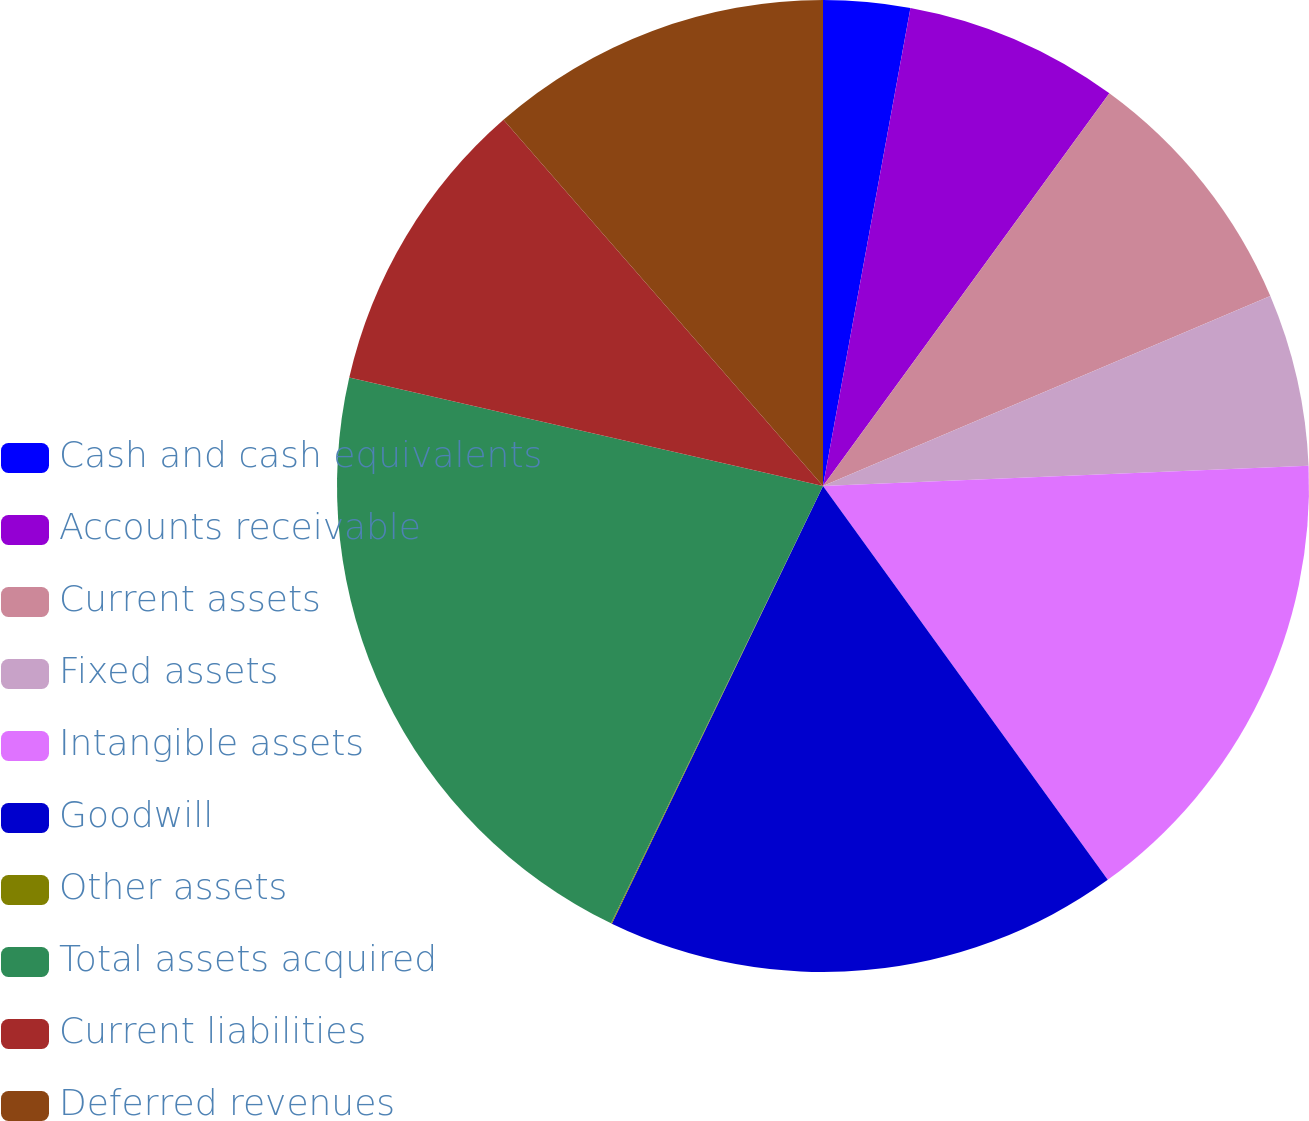Convert chart to OTSL. <chart><loc_0><loc_0><loc_500><loc_500><pie_chart><fcel>Cash and cash equivalents<fcel>Accounts receivable<fcel>Current assets<fcel>Fixed assets<fcel>Intangible assets<fcel>Goodwill<fcel>Other assets<fcel>Total assets acquired<fcel>Current liabilities<fcel>Deferred revenues<nl><fcel>2.88%<fcel>7.15%<fcel>8.58%<fcel>5.73%<fcel>15.7%<fcel>17.12%<fcel>0.03%<fcel>21.4%<fcel>10.0%<fcel>11.42%<nl></chart> 